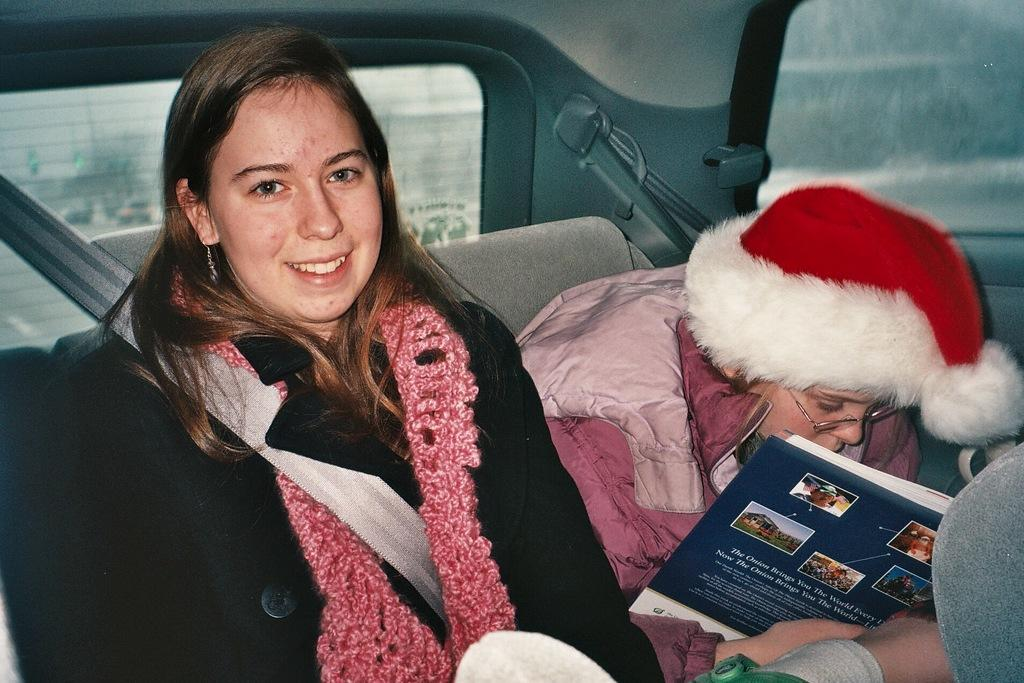How many people are in the vehicle in the image? There are two persons sitting in the vehicle in the image. What is the person on the right side of the image wearing? The person on the right side of the image is wearing a Christmas hat. What is the person on the right side of the image holding? The person on the right side of the image is holding a book. What type of lace can be seen in the image? There is no lace present in the image. What time of day is it in the image? The time of day is not specified in the image. 